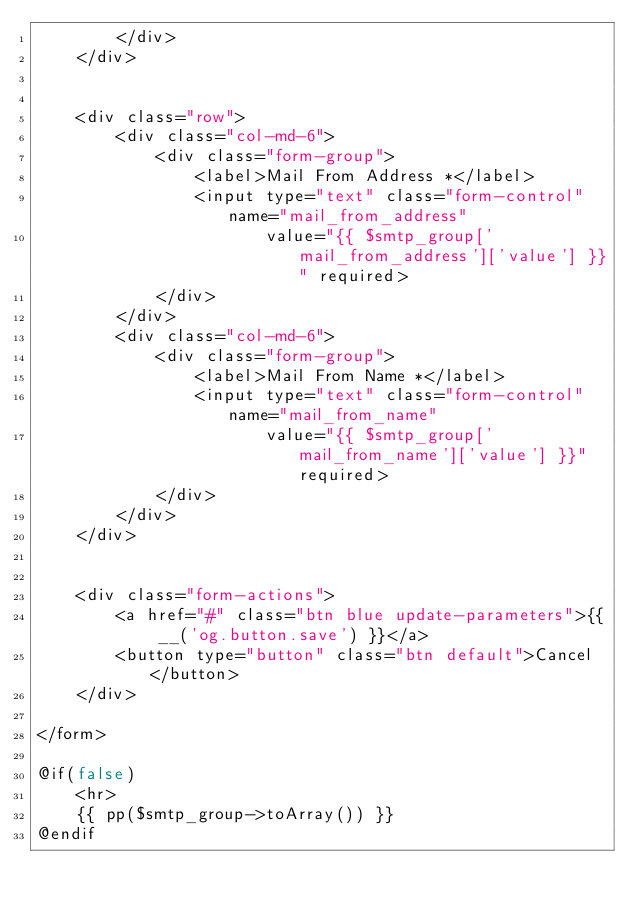<code> <loc_0><loc_0><loc_500><loc_500><_PHP_>        </div>
    </div>


    <div class="row">
        <div class="col-md-6">
            <div class="form-group">
                <label>Mail From Address *</label>
                <input type="text" class="form-control" name="mail_from_address"
                       value="{{ $smtp_group['mail_from_address']['value'] }}" required>
            </div>
        </div>
        <div class="col-md-6">
            <div class="form-group">
                <label>Mail From Name *</label>
                <input type="text" class="form-control" name="mail_from_name"
                       value="{{ $smtp_group['mail_from_name']['value'] }}" required>
            </div>
        </div>
    </div>


    <div class="form-actions">
        <a href="#" class="btn blue update-parameters">{{ __('og.button.save') }}</a>
        <button type="button" class="btn default">Cancel</button>
    </div>

</form>

@if(false)
    <hr>
    {{ pp($smtp_group->toArray()) }}
@endif
</code> 